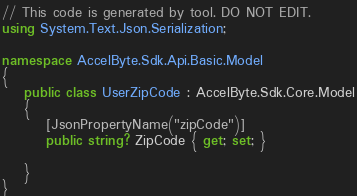Convert code to text. <code><loc_0><loc_0><loc_500><loc_500><_C#_>
// This code is generated by tool. DO NOT EDIT.
using System.Text.Json.Serialization;

namespace AccelByte.Sdk.Api.Basic.Model
{
    public class UserZipCode : AccelByte.Sdk.Core.Model
    {
        [JsonPropertyName("zipCode")]
        public string? ZipCode { get; set; }

    }
}</code> 